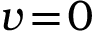Convert formula to latex. <formula><loc_0><loc_0><loc_500><loc_500>v \, = \, 0</formula> 